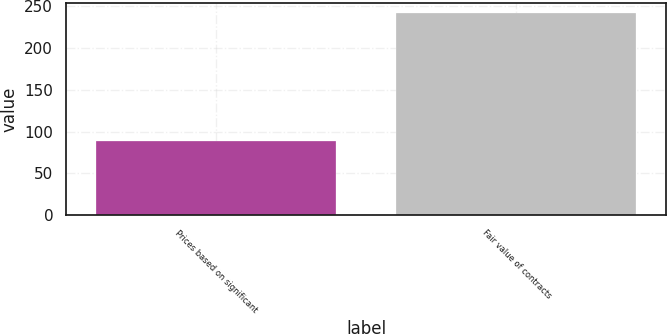Convert chart. <chart><loc_0><loc_0><loc_500><loc_500><bar_chart><fcel>Prices based on significant<fcel>Fair value of contracts<nl><fcel>89<fcel>242<nl></chart> 